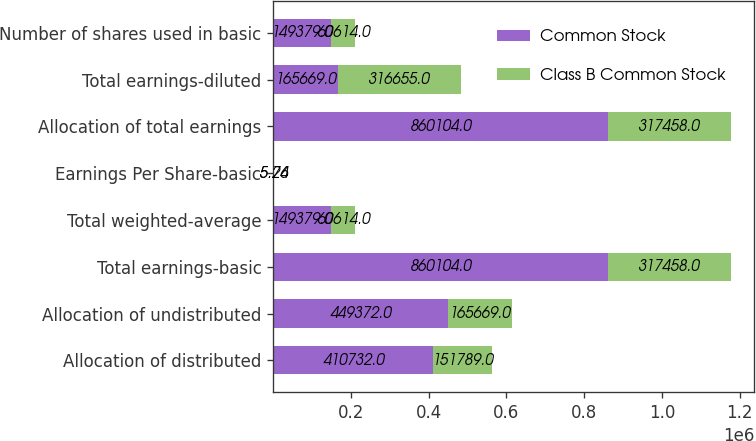<chart> <loc_0><loc_0><loc_500><loc_500><stacked_bar_chart><ecel><fcel>Allocation of distributed<fcel>Allocation of undistributed<fcel>Total earnings-basic<fcel>Total weighted-average<fcel>Earnings Per Share-basic<fcel>Allocation of total earnings<fcel>Total earnings-diluted<fcel>Number of shares used in basic<nl><fcel>Common Stock<fcel>410732<fcel>449372<fcel>860104<fcel>149379<fcel>5.76<fcel>860104<fcel>165669<fcel>149379<nl><fcel>Class B Common Stock<fcel>151789<fcel>165669<fcel>317458<fcel>60614<fcel>5.24<fcel>317458<fcel>316655<fcel>60614<nl></chart> 